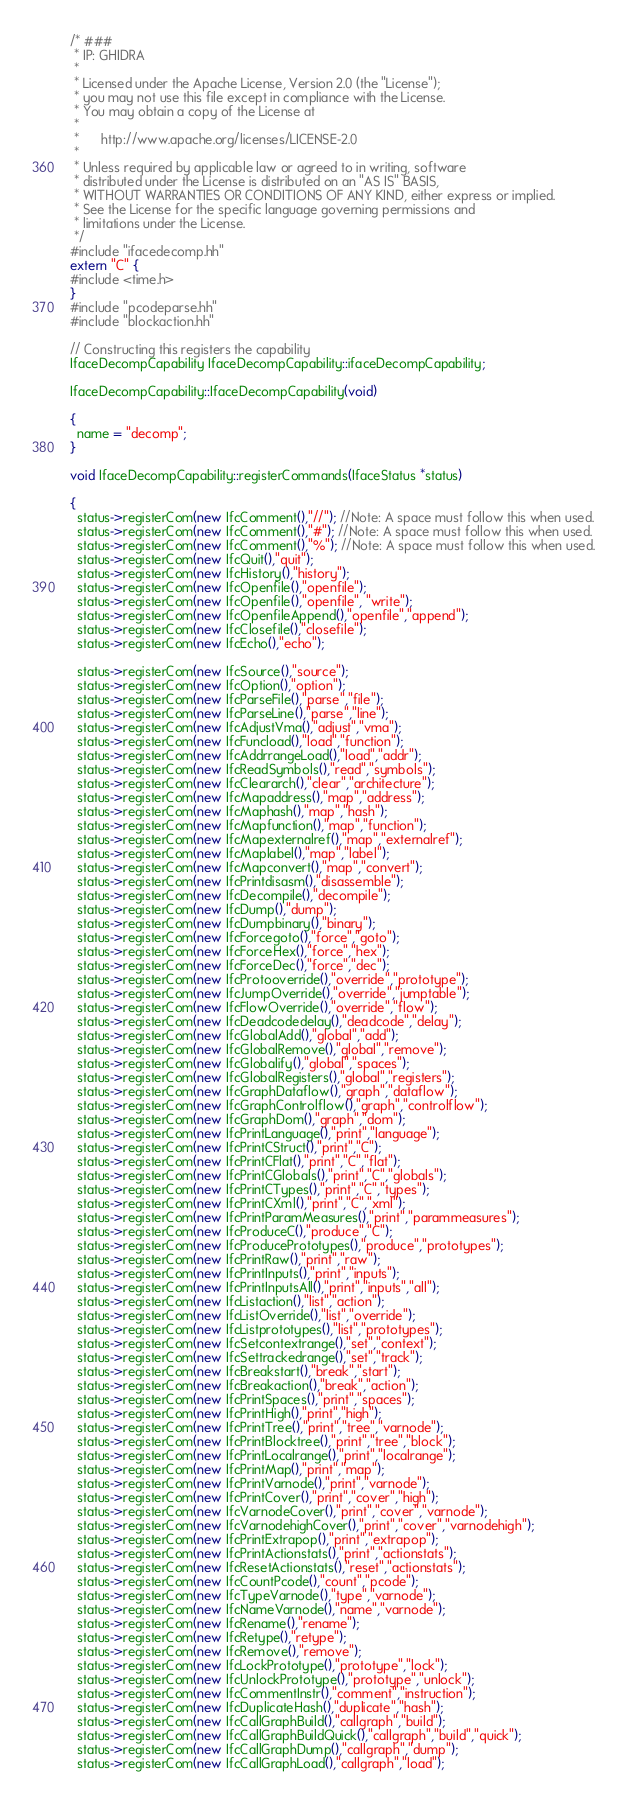<code> <loc_0><loc_0><loc_500><loc_500><_C++_>/* ###
 * IP: GHIDRA
 *
 * Licensed under the Apache License, Version 2.0 (the "License");
 * you may not use this file except in compliance with the License.
 * You may obtain a copy of the License at
 * 
 *      http://www.apache.org/licenses/LICENSE-2.0
 * 
 * Unless required by applicable law or agreed to in writing, software
 * distributed under the License is distributed on an "AS IS" BASIS,
 * WITHOUT WARRANTIES OR CONDITIONS OF ANY KIND, either express or implied.
 * See the License for the specific language governing permissions and
 * limitations under the License.
 */
#include "ifacedecomp.hh"
extern "C" {
#include <time.h>
}
#include "pcodeparse.hh"
#include "blockaction.hh"

// Constructing this registers the capability
IfaceDecompCapability IfaceDecompCapability::ifaceDecompCapability;

IfaceDecompCapability::IfaceDecompCapability(void)

{
  name = "decomp";
}

void IfaceDecompCapability::registerCommands(IfaceStatus *status)

{
  status->registerCom(new IfcComment(),"//"); //Note: A space must follow this when used.
  status->registerCom(new IfcComment(),"#"); //Note: A space must follow this when used.
  status->registerCom(new IfcComment(),"%"); //Note: A space must follow this when used.
  status->registerCom(new IfcQuit(),"quit");
  status->registerCom(new IfcHistory(),"history");
  status->registerCom(new IfcOpenfile(),"openfile");
  status->registerCom(new IfcOpenfile(),"openfile", "write");
  status->registerCom(new IfcOpenfileAppend(),"openfile","append");
  status->registerCom(new IfcClosefile(),"closefile");
  status->registerCom(new IfcEcho(),"echo");

  status->registerCom(new IfcSource(),"source");
  status->registerCom(new IfcOption(),"option");
  status->registerCom(new IfcParseFile(),"parse","file");
  status->registerCom(new IfcParseLine(),"parse","line");
  status->registerCom(new IfcAdjustVma(),"adjust","vma");
  status->registerCom(new IfcFuncload(),"load","function");
  status->registerCom(new IfcAddrrangeLoad(),"load","addr");
  status->registerCom(new IfcReadSymbols(),"read","symbols");
  status->registerCom(new IfcCleararch(),"clear","architecture");
  status->registerCom(new IfcMapaddress(),"map","address");
  status->registerCom(new IfcMaphash(),"map","hash");
  status->registerCom(new IfcMapfunction(),"map","function");
  status->registerCom(new IfcMapexternalref(),"map","externalref");
  status->registerCom(new IfcMaplabel(),"map","label");
  status->registerCom(new IfcMapconvert(),"map","convert");
  status->registerCom(new IfcPrintdisasm(),"disassemble");
  status->registerCom(new IfcDecompile(),"decompile");
  status->registerCom(new IfcDump(),"dump");
  status->registerCom(new IfcDumpbinary(),"binary");
  status->registerCom(new IfcForcegoto(),"force","goto");
  status->registerCom(new IfcForceHex(),"force","hex");
  status->registerCom(new IfcForceDec(),"force","dec");
  status->registerCom(new IfcProtooverride(),"override","prototype");
  status->registerCom(new IfcJumpOverride(),"override","jumptable");
  status->registerCom(new IfcFlowOverride(),"override","flow");
  status->registerCom(new IfcDeadcodedelay(),"deadcode","delay");
  status->registerCom(new IfcGlobalAdd(),"global","add");
  status->registerCom(new IfcGlobalRemove(),"global","remove");
  status->registerCom(new IfcGlobalify(),"global","spaces");
  status->registerCom(new IfcGlobalRegisters(),"global","registers");
  status->registerCom(new IfcGraphDataflow(),"graph","dataflow");
  status->registerCom(new IfcGraphControlflow(),"graph","controlflow");
  status->registerCom(new IfcGraphDom(),"graph","dom");
  status->registerCom(new IfcPrintLanguage(),"print","language");
  status->registerCom(new IfcPrintCStruct(),"print","C");
  status->registerCom(new IfcPrintCFlat(),"print","C","flat");
  status->registerCom(new IfcPrintCGlobals(),"print","C","globals");
  status->registerCom(new IfcPrintCTypes(),"print","C","types");
  status->registerCom(new IfcPrintCXml(),"print","C","xml");
  status->registerCom(new IfcPrintParamMeasures(),"print","parammeasures");
  status->registerCom(new IfcProduceC(),"produce","C");
  status->registerCom(new IfcProducePrototypes(),"produce","prototypes");
  status->registerCom(new IfcPrintRaw(),"print","raw");
  status->registerCom(new IfcPrintInputs(),"print","inputs");
  status->registerCom(new IfcPrintInputsAll(),"print","inputs","all");
  status->registerCom(new IfcListaction(),"list","action");
  status->registerCom(new IfcListOverride(),"list","override");
  status->registerCom(new IfcListprototypes(),"list","prototypes");
  status->registerCom(new IfcSetcontextrange(),"set","context");
  status->registerCom(new IfcSettrackedrange(),"set","track");
  status->registerCom(new IfcBreakstart(),"break","start");
  status->registerCom(new IfcBreakaction(),"break","action");
  status->registerCom(new IfcPrintSpaces(),"print","spaces");
  status->registerCom(new IfcPrintHigh(),"print","high");
  status->registerCom(new IfcPrintTree(),"print","tree","varnode");
  status->registerCom(new IfcPrintBlocktree(),"print","tree","block");
  status->registerCom(new IfcPrintLocalrange(),"print","localrange");
  status->registerCom(new IfcPrintMap(),"print","map");
  status->registerCom(new IfcPrintVarnode(),"print","varnode");
  status->registerCom(new IfcPrintCover(),"print","cover","high");
  status->registerCom(new IfcVarnodeCover(),"print","cover","varnode");
  status->registerCom(new IfcVarnodehighCover(),"print","cover","varnodehigh");
  status->registerCom(new IfcPrintExtrapop(),"print","extrapop");
  status->registerCom(new IfcPrintActionstats(),"print","actionstats");
  status->registerCom(new IfcResetActionstats(),"reset","actionstats");
  status->registerCom(new IfcCountPcode(),"count","pcode");
  status->registerCom(new IfcTypeVarnode(),"type","varnode");
  status->registerCom(new IfcNameVarnode(),"name","varnode");
  status->registerCom(new IfcRename(),"rename");
  status->registerCom(new IfcRetype(),"retype");
  status->registerCom(new IfcRemove(),"remove");
  status->registerCom(new IfcLockPrototype(),"prototype","lock");
  status->registerCom(new IfcUnlockPrototype(),"prototype","unlock");
  status->registerCom(new IfcCommentInstr(),"comment","instruction");
  status->registerCom(new IfcDuplicateHash(),"duplicate","hash");
  status->registerCom(new IfcCallGraphBuild(),"callgraph","build");
  status->registerCom(new IfcCallGraphBuildQuick(),"callgraph","build","quick");
  status->registerCom(new IfcCallGraphDump(),"callgraph","dump");
  status->registerCom(new IfcCallGraphLoad(),"callgraph","load");</code> 